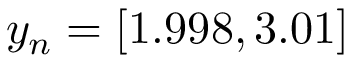<formula> <loc_0><loc_0><loc_500><loc_500>y _ { n } = [ 1 . 9 9 8 , 3 . 0 1 ]</formula> 